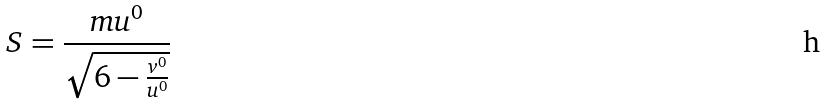Convert formula to latex. <formula><loc_0><loc_0><loc_500><loc_500>S = \frac { m u ^ { 0 } } { \sqrt { 6 - \frac { v ^ { 0 } } { u ^ { 0 } } } }</formula> 